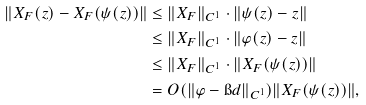<formula> <loc_0><loc_0><loc_500><loc_500>\label l { e q \colon z p s i } \| X _ { F } ( z ) - X _ { F } ( \psi ( z ) ) \| & \leq \| X _ { F } \| _ { C ^ { 1 } } \cdot \| \psi ( z ) - z \| \\ & \leq \| X _ { F } \| _ { C ^ { 1 } } \cdot \| \varphi ( z ) - z \| \\ & \leq \| X _ { F } \| _ { C ^ { 1 } } \cdot \| X _ { F } ( \psi ( z ) ) \| \\ & = O ( \| \varphi - \i d \| _ { C ^ { 1 } } ) \| X _ { F } ( \psi ( z ) ) \| ,</formula> 